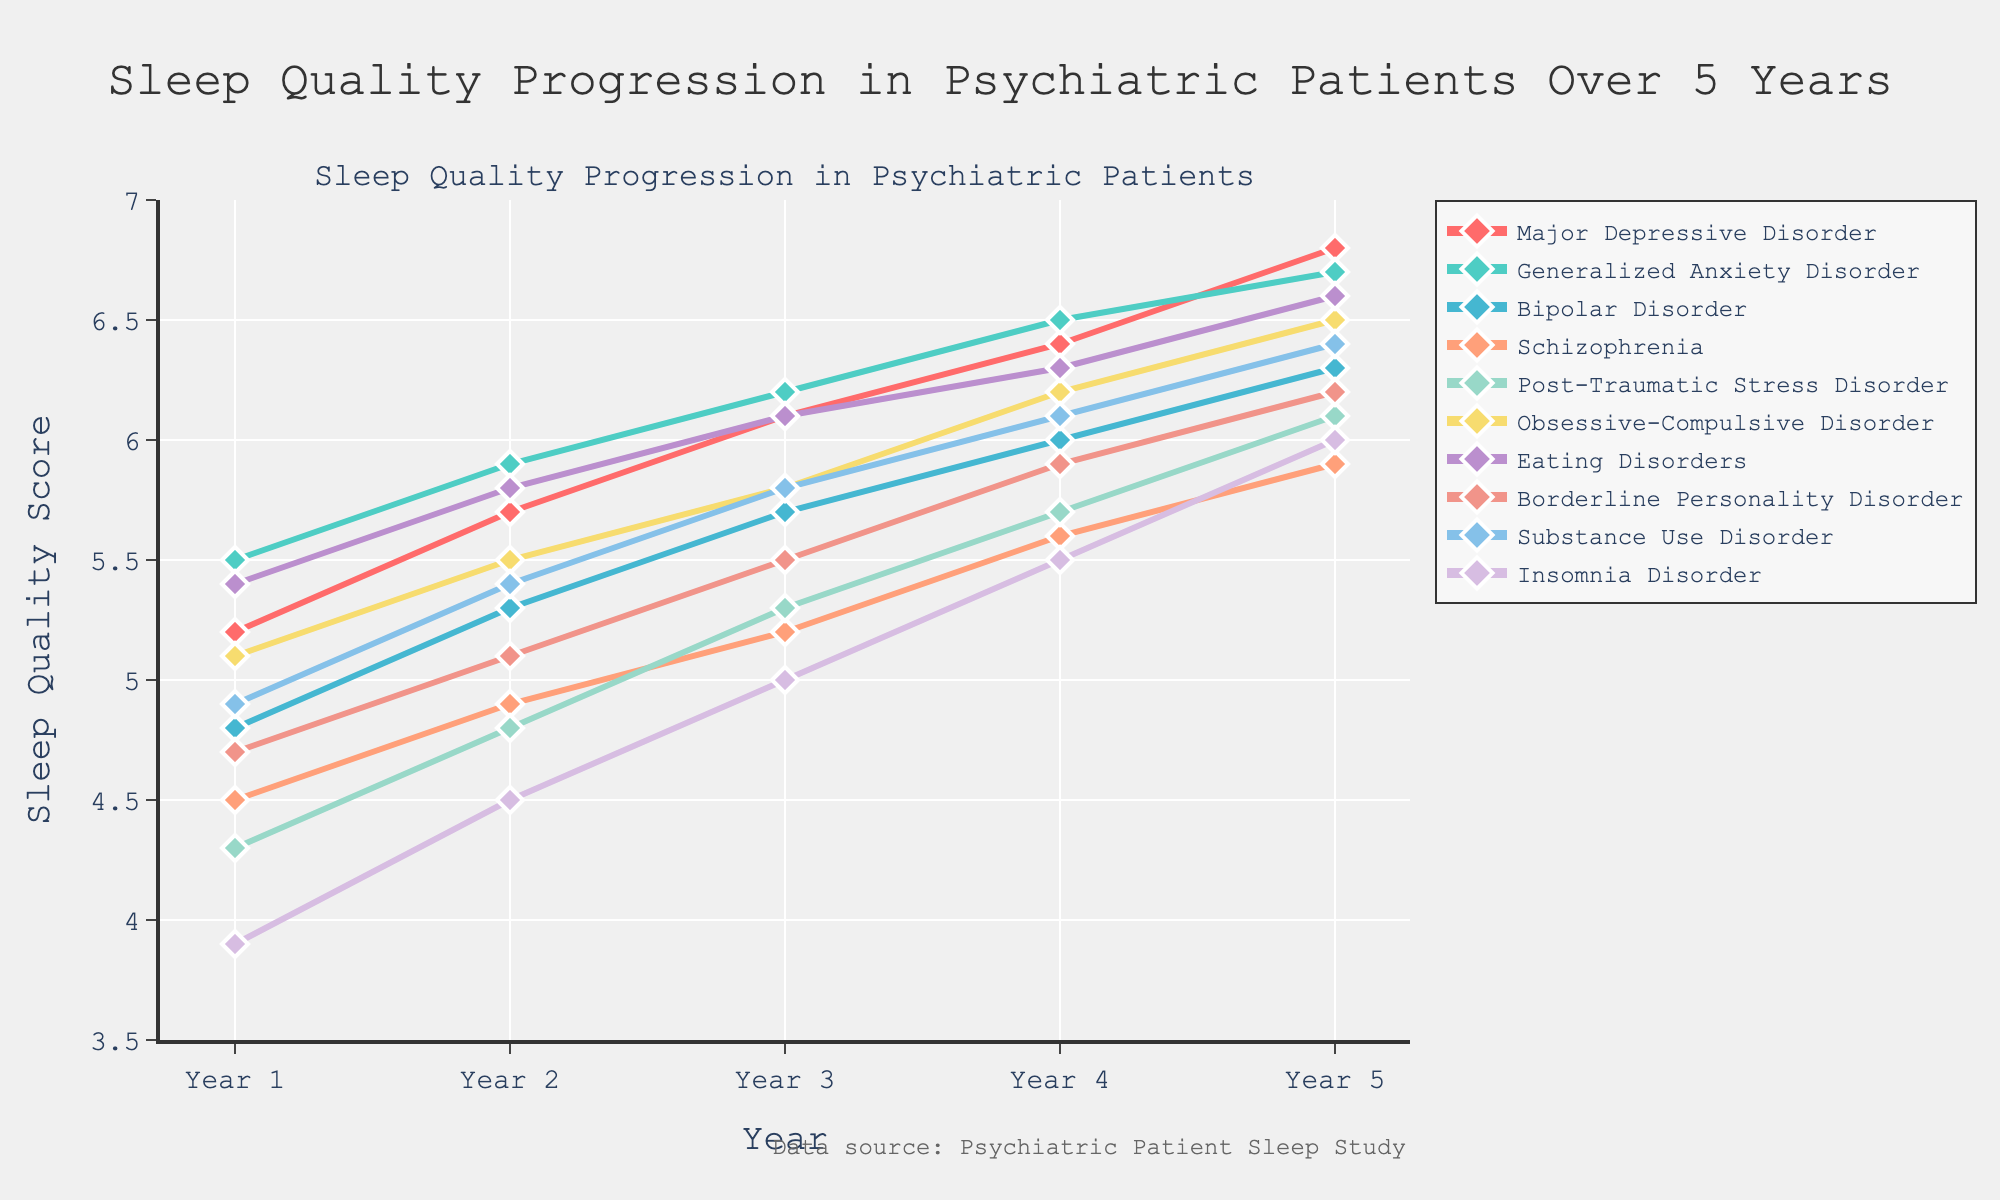Which diagnosis shows the greatest improvement in sleep quality over the 5-year period? To determine this, calculate the difference between the sleep quality score in Year 5 and Year 1 for each diagnosis, then find the diagnosis with the largest difference. For example, Major Depressive Disorder improved by 6.8 - 5.2 = 1.6. Repeat this for all diagnoses.
Answer: Insomnia Disorder Which diagnosis had the least sleep quality improvement between Year 1 and Year 5? Similarly, calculate the difference for each diagnosis between Year 1 and Year 5, then identify the smallest difference.
Answer: Generalized Anxiety Disorder How does the sleep quality score of Bipolar Disorder in Year 3 compare to Schizophrenia in Year 3? Locate the values for Bipolar Disorder in Year 3 (5.7) and Schizophrenia in Year 3 (5.2). Compare these two values.
Answer: Bipolar Disorder’s score is higher What is the average sleep quality score for Obsessive-Compulsive Disorder over the 5 years? Add the sleep quality scores for Obsessive-Compulsive Disorder from Year 1 to Year 5 (5.1 + 5.5 + 5.8 + 6.2 + 6.5), then divide by 5 to find the average.
Answer: 5.82 Which diagnoses have an average sleep quality score above 6.0 across the 5 years? Calculate the average score for each diagnosis by summing the yearly scores and dividing by 5. Identify which averages are above 6.0.
Answer: Major Depressive Disorder, Generalized Anxiety Disorder, Eating Disorders In which year does Post-Traumatic Stress Disorder show the largest increment in sleep quality compared to the previous year? Calculate the yearly increments for Post-Traumatic Stress Disorder: Year 2 - Year 1 (4.8 - 4.3), Year 3 - Year 2 (5.3 - 4.8), Year 4 - Year 3 (5.7 - 5.3), and Year 5 - Year 4 (6.1 - 5.7). Identify the largest increment.
Answer: Year 2 to Year 3 Compare the sleep quality trends for Borderline Personality Disorder and Substance Use Disorder over the 5 years. Analyze the plotted lines for both diagnoses. See if both lines are increasing, decreasing, or showing a similar pattern. Check for any crossover points.
Answer: Both increase similarly What is the difference between the sleep quality scores of Major Depressive Disorder and Schizophrenia in Year 5? Subtract Schizophrenia's Year 5 score (5.9) from Major Depressive Disorder's Year 5 score (6.8).
Answer: 0.9 